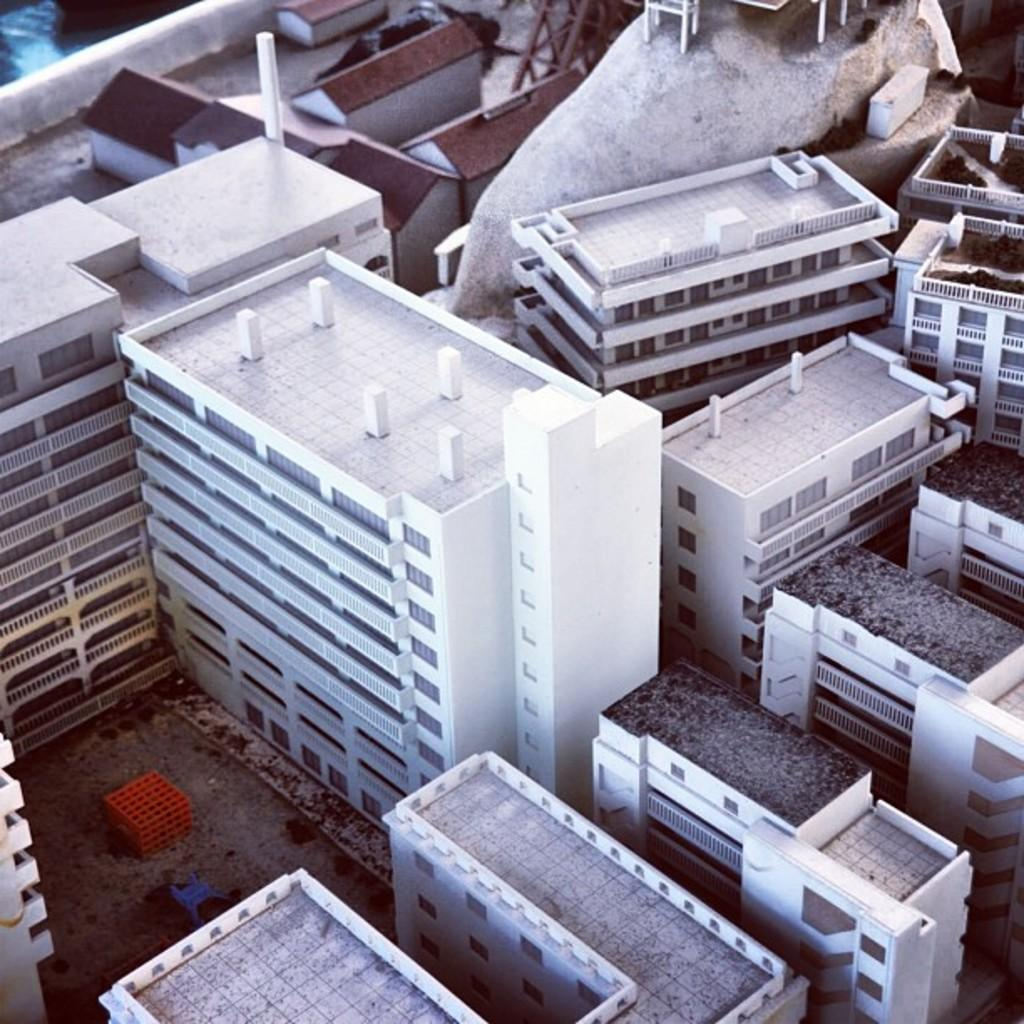What type of structures are present in the image? There are buildings in the image. Can you describe the colors of the buildings? The buildings have different colors, including white, brown, and black. What can be seen beneath the buildings in the image? There is ground visible in the image. What colors are the objects on the ground? The objects on the ground are blue and red. How does the horn affect the temper of the men in the image? There is no horn or men present in the image, so this question cannot be answered. 